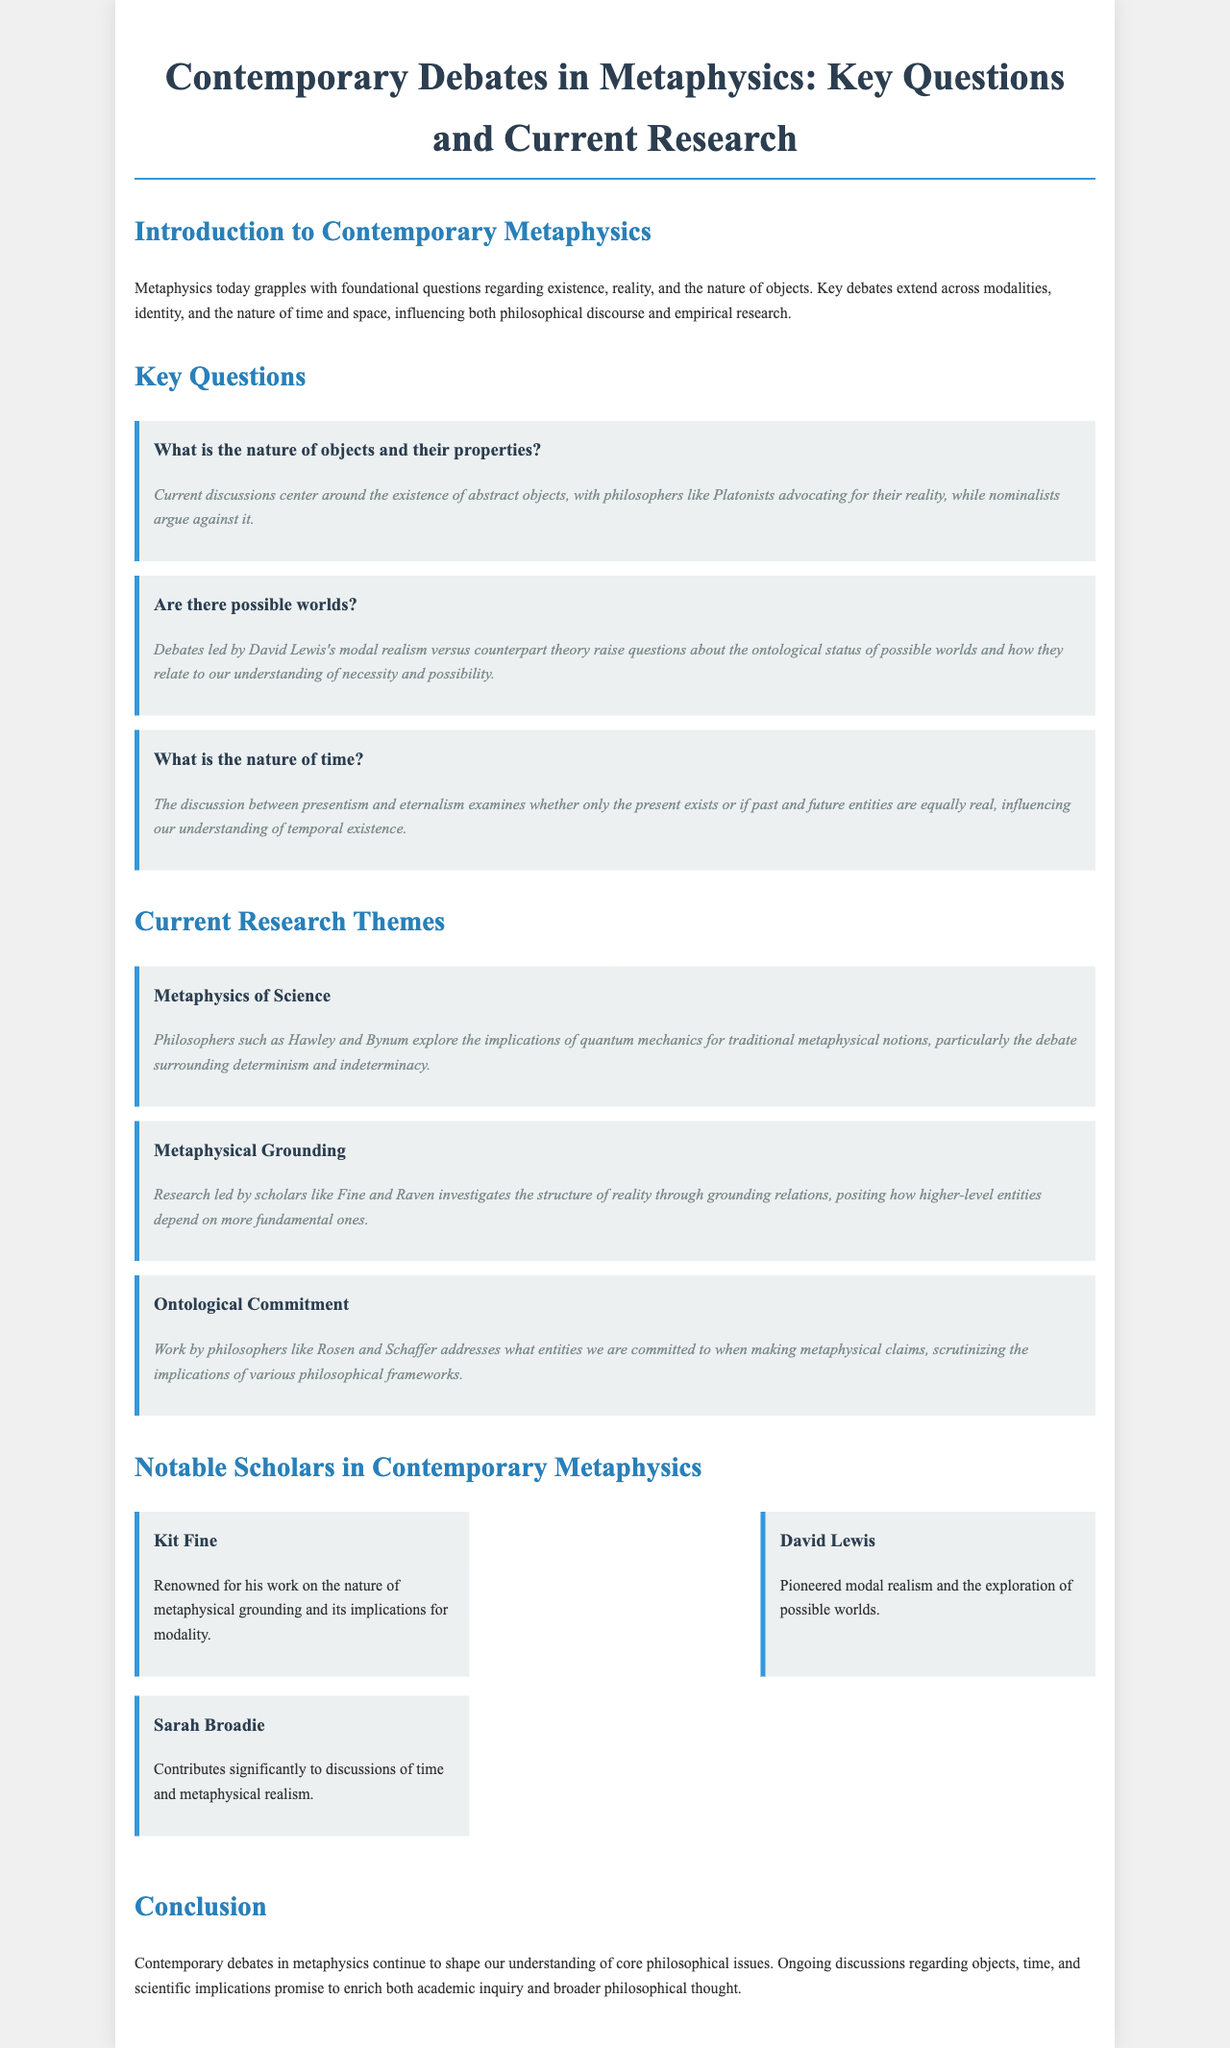What is the main focus of contemporary metaphysics? The main focus is on foundational questions regarding existence, reality, and the nature of objects.
Answer: Foundational questions regarding existence, reality, and the nature of objects Who advocates for the reality of abstract objects? Platonists are mentioned as those who advocate for the reality of abstract objects in the document.
Answer: Platonists What philosophical position examines whether only the present exists? Presentism examines the position about the existence of only the present.
Answer: Presentism Which philosophers explore quantum mechanics in relation to metaphysics? Hawley and Bynum are noted for exploring the implications of quantum mechanics for metaphysical notions.
Answer: Hawley and Bynum Who pioneered the concept of modal realism? David Lewis is recognized for pioneering modal realism.
Answer: David Lewis What theme investigates grounding relations in reality? The theme focusing on the structure of reality through grounding relations is "Metaphysical Grounding."
Answer: Metaphysical Grounding Which scholar is known for contributions to discussions of time? Sarah Broadie is mentioned as contributing significantly to discussions of time.
Answer: Sarah Broadie What are the two contrasting views on the nature of time? Presentism and eternalism are the two contrasting views highlighted in the document.
Answer: Presentism and eternalism Which question addresses the ontological status of possible worlds? The question "Are there possible worlds?" addresses the ontological status of possible worlds.
Answer: Are there possible worlds? 